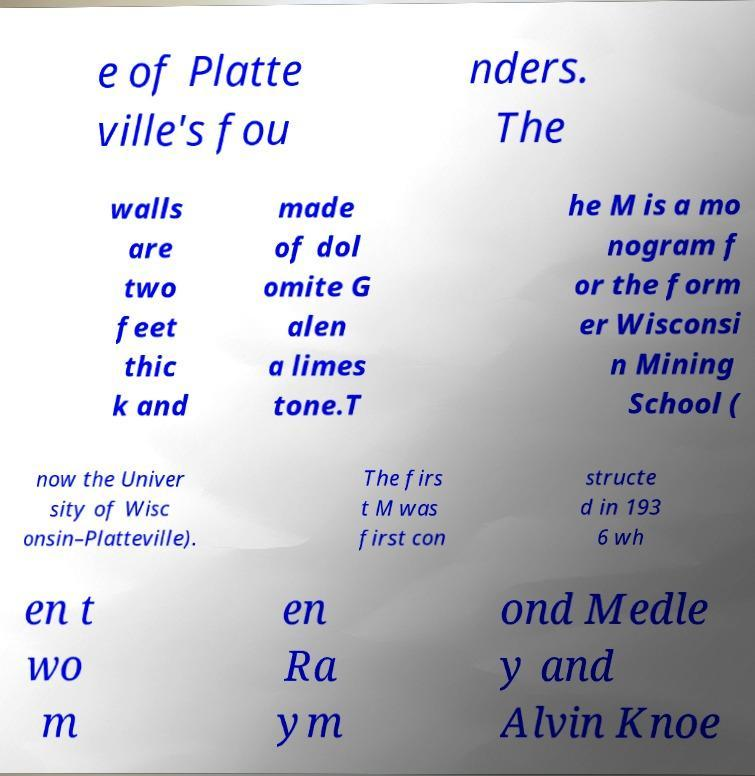Please identify and transcribe the text found in this image. e of Platte ville's fou nders. The walls are two feet thic k and made of dol omite G alen a limes tone.T he M is a mo nogram f or the form er Wisconsi n Mining School ( now the Univer sity of Wisc onsin–Platteville). The firs t M was first con structe d in 193 6 wh en t wo m en Ra ym ond Medle y and Alvin Knoe 